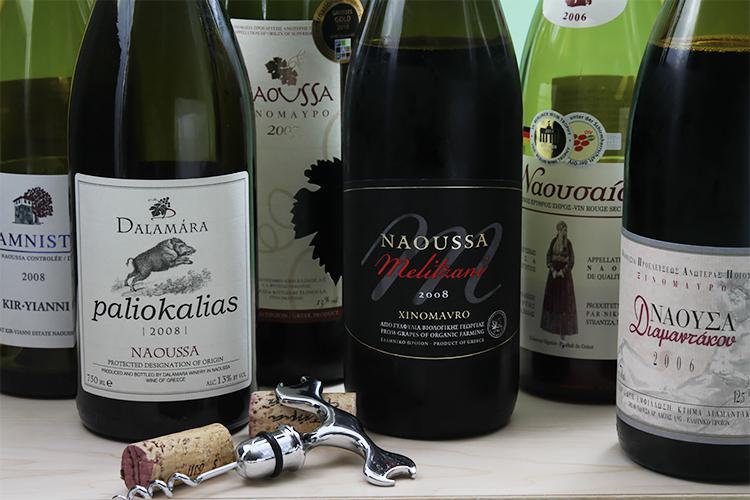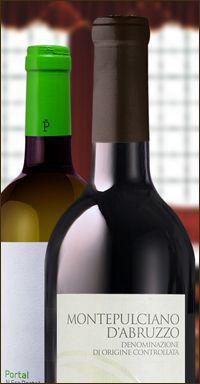The first image is the image on the left, the second image is the image on the right. Analyze the images presented: Is the assertion "There is a wine glass visible on one of the images." valid? Answer yes or no. No. 